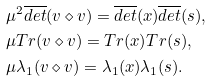Convert formula to latex. <formula><loc_0><loc_0><loc_500><loc_500>& \mu ^ { 2 } \overline { d e t } ( v \diamond v ) = \overline { d e t } ( x ) \overline { d e t } ( s ) , \\ & \mu T r ( v \diamond v ) = T r ( x ) T r ( s ) , \\ & \mu \lambda _ { 1 } ( v \diamond v ) = \lambda _ { 1 } ( x ) \lambda _ { 1 } ( s ) .</formula> 